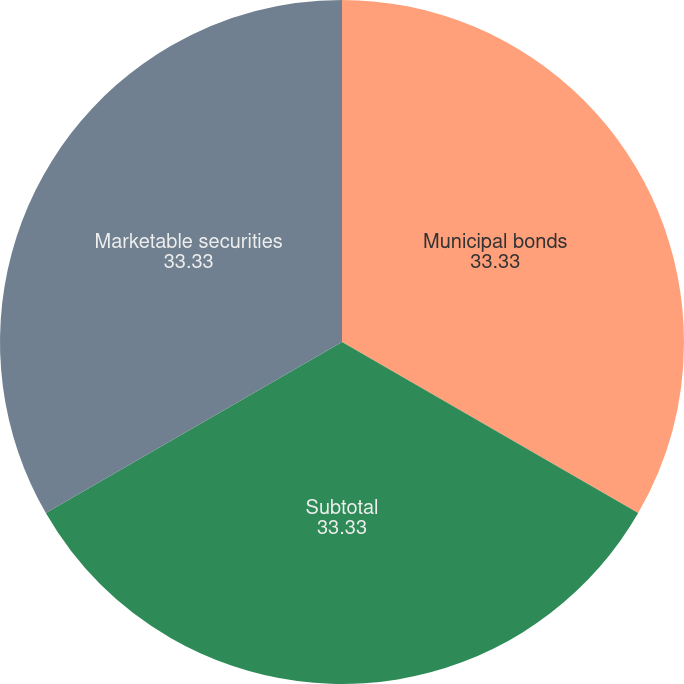<chart> <loc_0><loc_0><loc_500><loc_500><pie_chart><fcel>Municipal bonds<fcel>Subtotal<fcel>Marketable securities<nl><fcel>33.33%<fcel>33.33%<fcel>33.33%<nl></chart> 